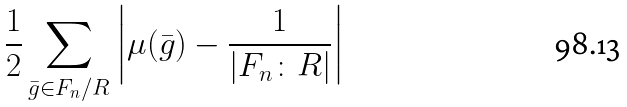Convert formula to latex. <formula><loc_0><loc_0><loc_500><loc_500>\frac { 1 } { 2 } \sum _ { \bar { g } \in F _ { n } / R } \left | \mu ( \bar { g } ) - \frac { 1 } { | F _ { n } \colon R | } \right |</formula> 